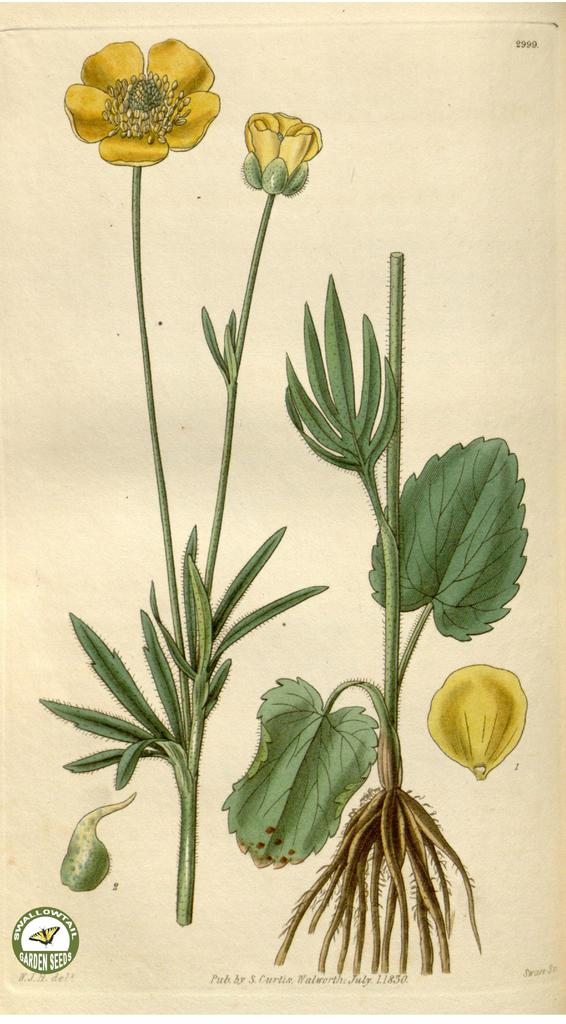What type of drawings can be seen in the image? There are drawings of plants and flowers in the image. What is the medium for these drawings? The drawings are on a paper. How does the family interact with the steam coming from the bun in the image? There is no family, steam, or bun present in the image; it only features drawings of plants and flowers on a paper. 